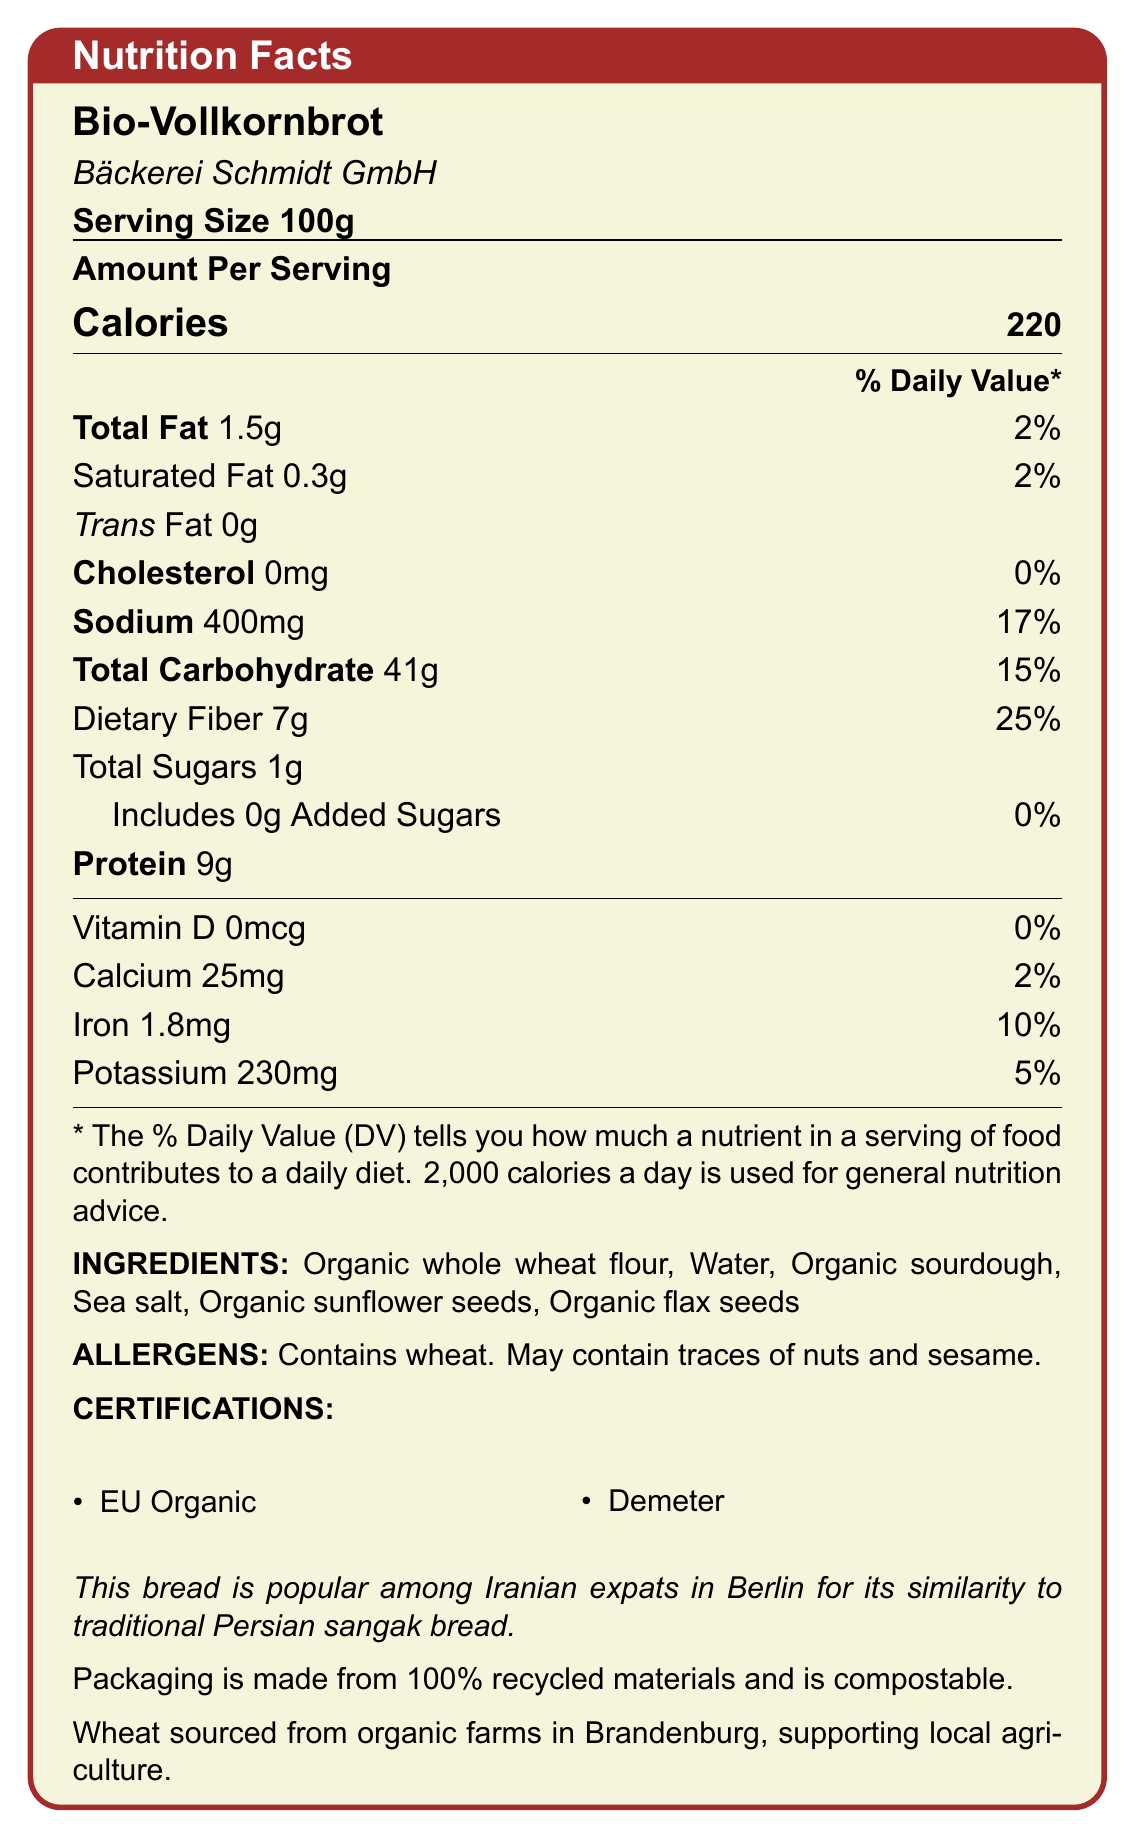what is the serving size? The document specifies the serving size as 100g.
Answer: 100g How much dietary fiber is in one serving of Bio-Vollkornbrot? The document lists dietary fiber as 7g per serving.
Answer: 7g What percentage of the daily value of protein does one serving of Bio-Vollkornbrot provide? The document lists the amount of protein as 9g but does not specify the daily value percentage for protein.
Answer: Not specified Is there any added sugar in Bio-Vollkornbrot? The document states that added sugars are 0g, which means there are no added sugars.
Answer: No Which company manufactures Bio-Vollkornbrot? The manufacturer is stated as Bäckerei Schmidt GmbH in the document.
Answer: Bäckerei Schmidt GmbH What could be an allergen in this bread? The document lists wheat as a contained allergen and mentions it may contain traces of nuts and sesame.
Answer: Wheat What is the main source of fiber in this bread? A. Organic whole wheat flour B. Organic sunflower seeds C. Organic flax seeds D. Sea salt The main ingredient, organic whole wheat flour, is the primary source of dietary fiber in bread.
Answer: A. Organic whole wheat flour What certifications does Bio-Vollkornbrot have? A. USDA Organic B. EU Organic C. Fair Trade D. Demeter The document lists EU Organic and Demeter as the certifications for the bread. USDA Organic and Fair Trade are not mentioned.
Answer: B. EU Organic, D. Demeter Is Bio-Vollkornbrot free from cholesterol? The document states that the amount of cholesterol is 0mg.
Answer: Yes Summarize the key features of Bio-Vollkornbrot's nutrition facts label and additional information. The summary captures the nutrition facts and additional contextual information provided in the document, giving an overall view of the product's nutritional value, ingredients, certifications, cultural significance, and sustainability.
Answer: Bio-Vollkornbrot, manufactured by Bäckerei Schmidt GmbH, provides 220 calories per 100g serving. It contains 1.5g total fat, 0.3g saturated fat, 0g trans fat, 0mg cholesterol, 400mg sodium, 41g total carbohydrate, 7g dietary fiber, 1g total sugars, 0g added sugars, 9g protein, and small amounts of vitamins and minerals. The bread is made from organic whole wheat flour, water, organic sourdough, sea salt, organic sunflower seeds, and organic flax seeds, and is certified by EU Organic and Demeter. It is popular among Iranian expats in Berlin for its likeness to Persian sangak bread. The packaging is sustainable, and ingredients are sourced locally. What is the main reason for the bread's popularity among Iranian expats in Berlin? The document mentions that this bread is popular among Iranian expats in Berlin due to its similarity to traditional Persian sangak bread.
Answer: Similarity to traditional Persian sangak bread How many milligrams of potassium are in one serving of Bio-Vollkornbrot? The document specifies that each serving contains 230mg of potassium.
Answer: 230mg Does Bio-Vollkornbrot contain any Vitamin D? The document states that Vitamin D is 0mcg, indicating the bread contains no Vitamin D.
Answer: No What is the total percentage of daily value for sodium in Bio-Vollkornbrot per serving? The document lists the daily value percentage for sodium as 17%.
Answer: 17% How many grams of total fat are in Bio-Vollkornbrot? The document lists total fat as 1.5g per serving.
Answer: 1.5g Which ingredient in Bio-Vollkornbrot supports local agriculture in Brandenburg? The document specifies that wheat is sourced from organic farms in Brandenburg, supporting local agriculture.
Answer: Organic whole wheat flour How would you describe the energy content of Bio-Vollkornbrot in terms of calories? With 220 calories per 100g serving, the bread provides a moderate amount of energy.
Answer: Moderate What is the primary source of fats in Bio-Vollkornbrot? The document lists organic sunflower seeds and organic flax seeds as ingredients, which are common sources of fats.
Answer: Organic sunflower and flax seeds Can you find the source of the packaging materials for Bio-Vollkornbrot? The document mentions that the packaging is made from 100% recycled materials and is compostable.
Answer: 100% recycled materials, compostable What is the total carbohydrate content of one serving of Bio-Vollkornbrot? The document lists total carbohydrates at 41g per serving.
Answer: 41g What percentage of the daily value for calcium does one serving of Bio-Vollkornbrot contain? The document specifies that each serving provides 2% of the daily value for calcium.
Answer: 2% 